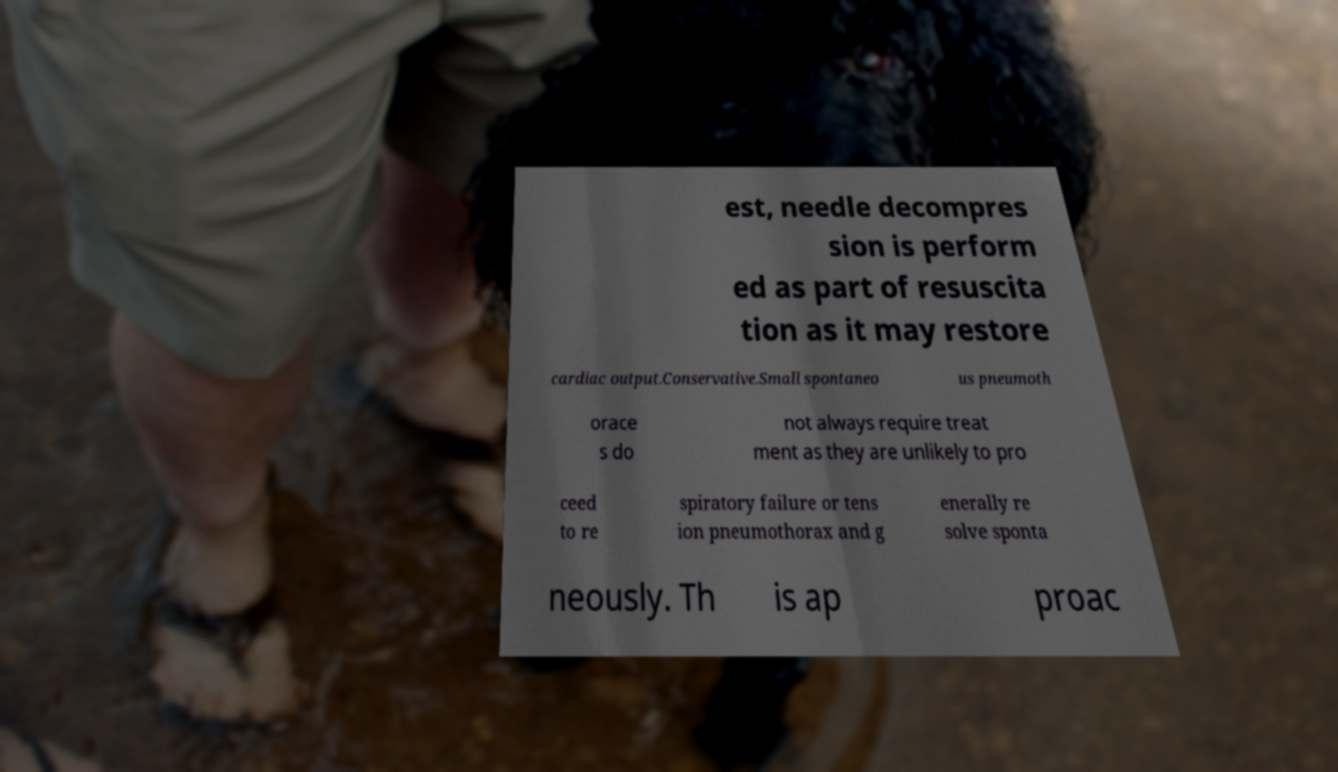Could you assist in decoding the text presented in this image and type it out clearly? est, needle decompres sion is perform ed as part of resuscita tion as it may restore cardiac output.Conservative.Small spontaneo us pneumoth orace s do not always require treat ment as they are unlikely to pro ceed to re spiratory failure or tens ion pneumothorax and g enerally re solve sponta neously. Th is ap proac 